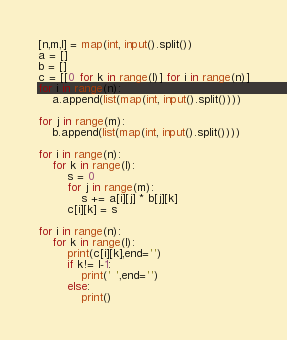Convert code to text. <code><loc_0><loc_0><loc_500><loc_500><_Python_>[n,m,l] = map(int, input().split())
a = []
b = []
c = [[0 for k in range(l)] for i in range(n)]
for i in range(n):
    a.append(list(map(int, input().split())))

for j in range(m):
    b.append(list(map(int, input().split())))

for i in range(n):
    for k in range(l):
        s = 0
        for j in range(m):
            s += a[i][j] * b[j][k]
        c[i][k] = s

for i in range(n):
    for k in range(l):
        print(c[i][k],end='')
        if k!= l-1:    
            print(' ',end='')
        else:
            print()</code> 